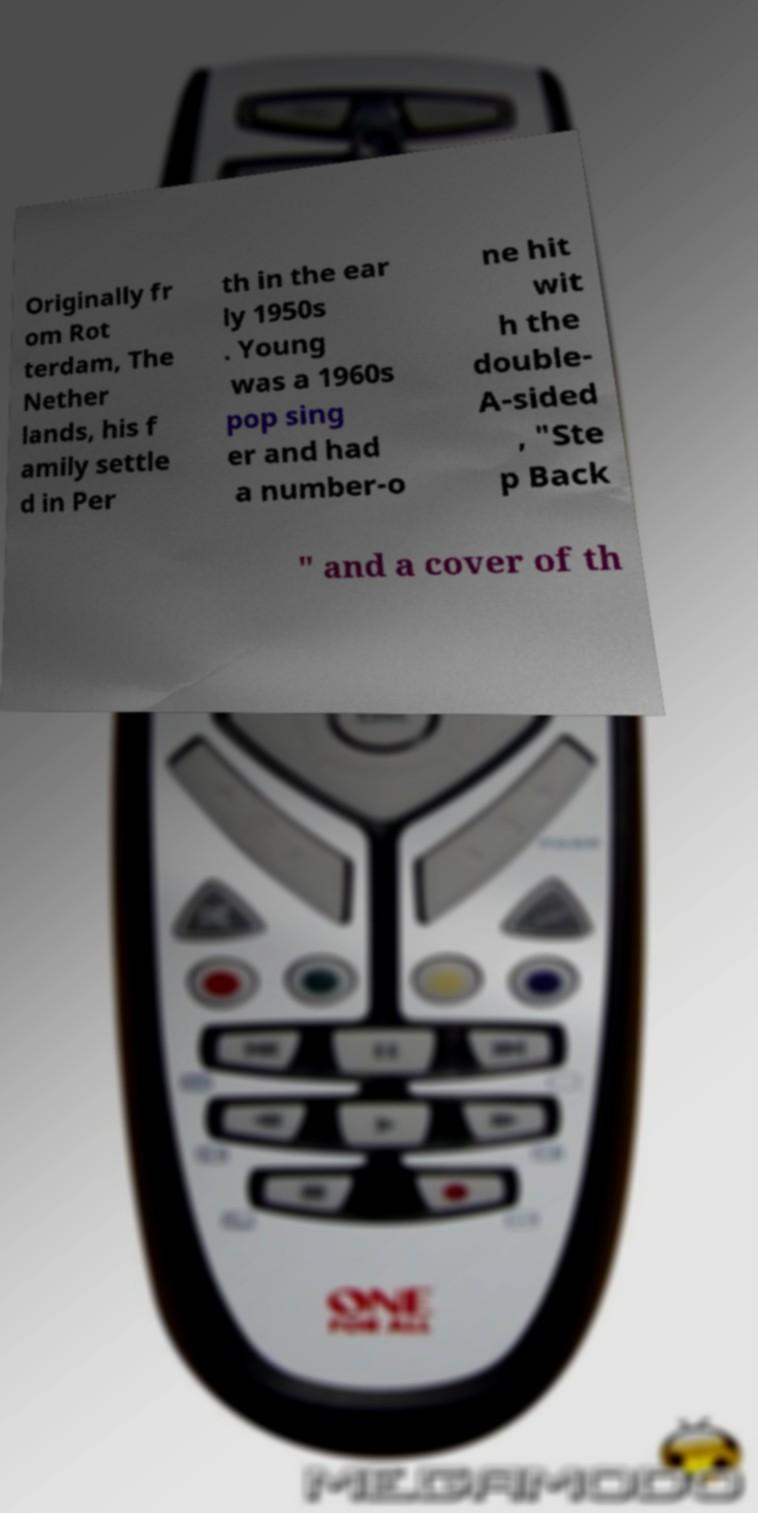Please identify and transcribe the text found in this image. Originally fr om Rot terdam, The Nether lands, his f amily settle d in Per th in the ear ly 1950s . Young was a 1960s pop sing er and had a number-o ne hit wit h the double- A-sided , "Ste p Back " and a cover of th 